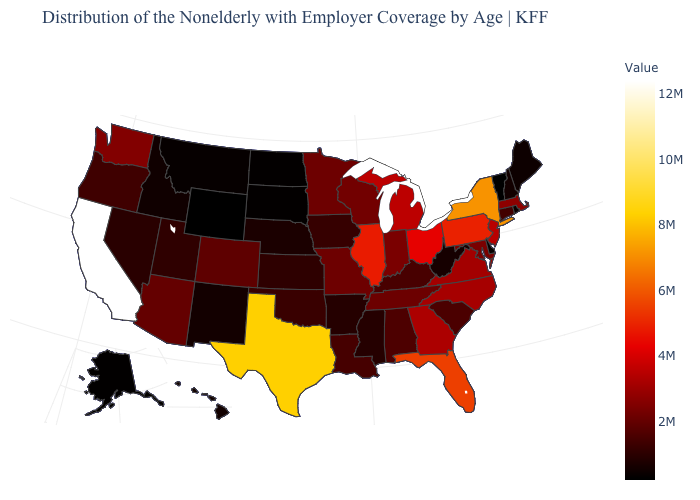Which states hav the highest value in the South?
Concise answer only. Texas. Among the states that border New Jersey , which have the highest value?
Give a very brief answer. New York. Which states hav the highest value in the Northeast?
Answer briefly. New York. Does Vermont have the lowest value in the USA?
Keep it brief. Yes. Is the legend a continuous bar?
Write a very short answer. Yes. Does the map have missing data?
Concise answer only. No. Does North Dakota have the lowest value in the MidWest?
Concise answer only. Yes. Which states have the highest value in the USA?
Give a very brief answer. California. Which states hav the highest value in the South?
Write a very short answer. Texas. Which states hav the highest value in the West?
Write a very short answer. California. 